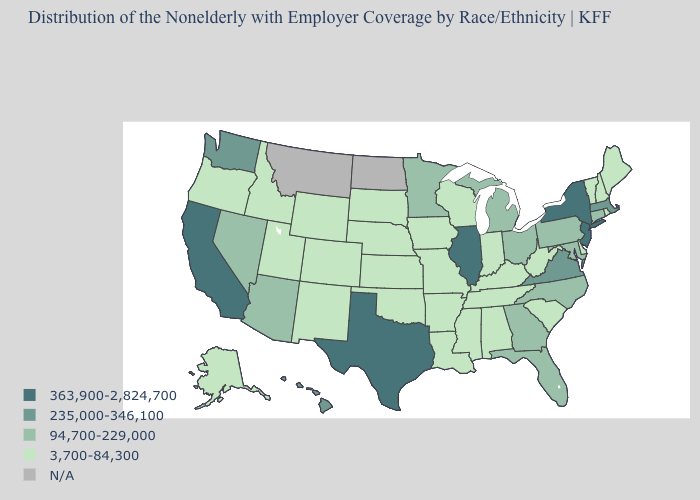What is the value of Tennessee?
Answer briefly. 3,700-84,300. What is the value of Rhode Island?
Be succinct. 3,700-84,300. What is the value of Arkansas?
Write a very short answer. 3,700-84,300. How many symbols are there in the legend?
Short answer required. 5. Name the states that have a value in the range 363,900-2,824,700?
Concise answer only. California, Illinois, New Jersey, New York, Texas. Which states have the lowest value in the USA?
Write a very short answer. Alabama, Alaska, Arkansas, Colorado, Delaware, Idaho, Indiana, Iowa, Kansas, Kentucky, Louisiana, Maine, Mississippi, Missouri, Nebraska, New Hampshire, New Mexico, Oklahoma, Oregon, Rhode Island, South Carolina, South Dakota, Tennessee, Utah, Vermont, West Virginia, Wisconsin, Wyoming. What is the lowest value in states that border New Jersey?
Answer briefly. 3,700-84,300. What is the lowest value in the MidWest?
Write a very short answer. 3,700-84,300. Is the legend a continuous bar?
Concise answer only. No. What is the value of Indiana?
Give a very brief answer. 3,700-84,300. What is the lowest value in states that border Minnesota?
Concise answer only. 3,700-84,300. Name the states that have a value in the range 3,700-84,300?
Give a very brief answer. Alabama, Alaska, Arkansas, Colorado, Delaware, Idaho, Indiana, Iowa, Kansas, Kentucky, Louisiana, Maine, Mississippi, Missouri, Nebraska, New Hampshire, New Mexico, Oklahoma, Oregon, Rhode Island, South Carolina, South Dakota, Tennessee, Utah, Vermont, West Virginia, Wisconsin, Wyoming. What is the highest value in states that border Montana?
Quick response, please. 3,700-84,300. Name the states that have a value in the range 363,900-2,824,700?
Write a very short answer. California, Illinois, New Jersey, New York, Texas. 